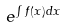Convert formula to latex. <formula><loc_0><loc_0><loc_500><loc_500>e ^ { \int f ( x ) d x }</formula> 